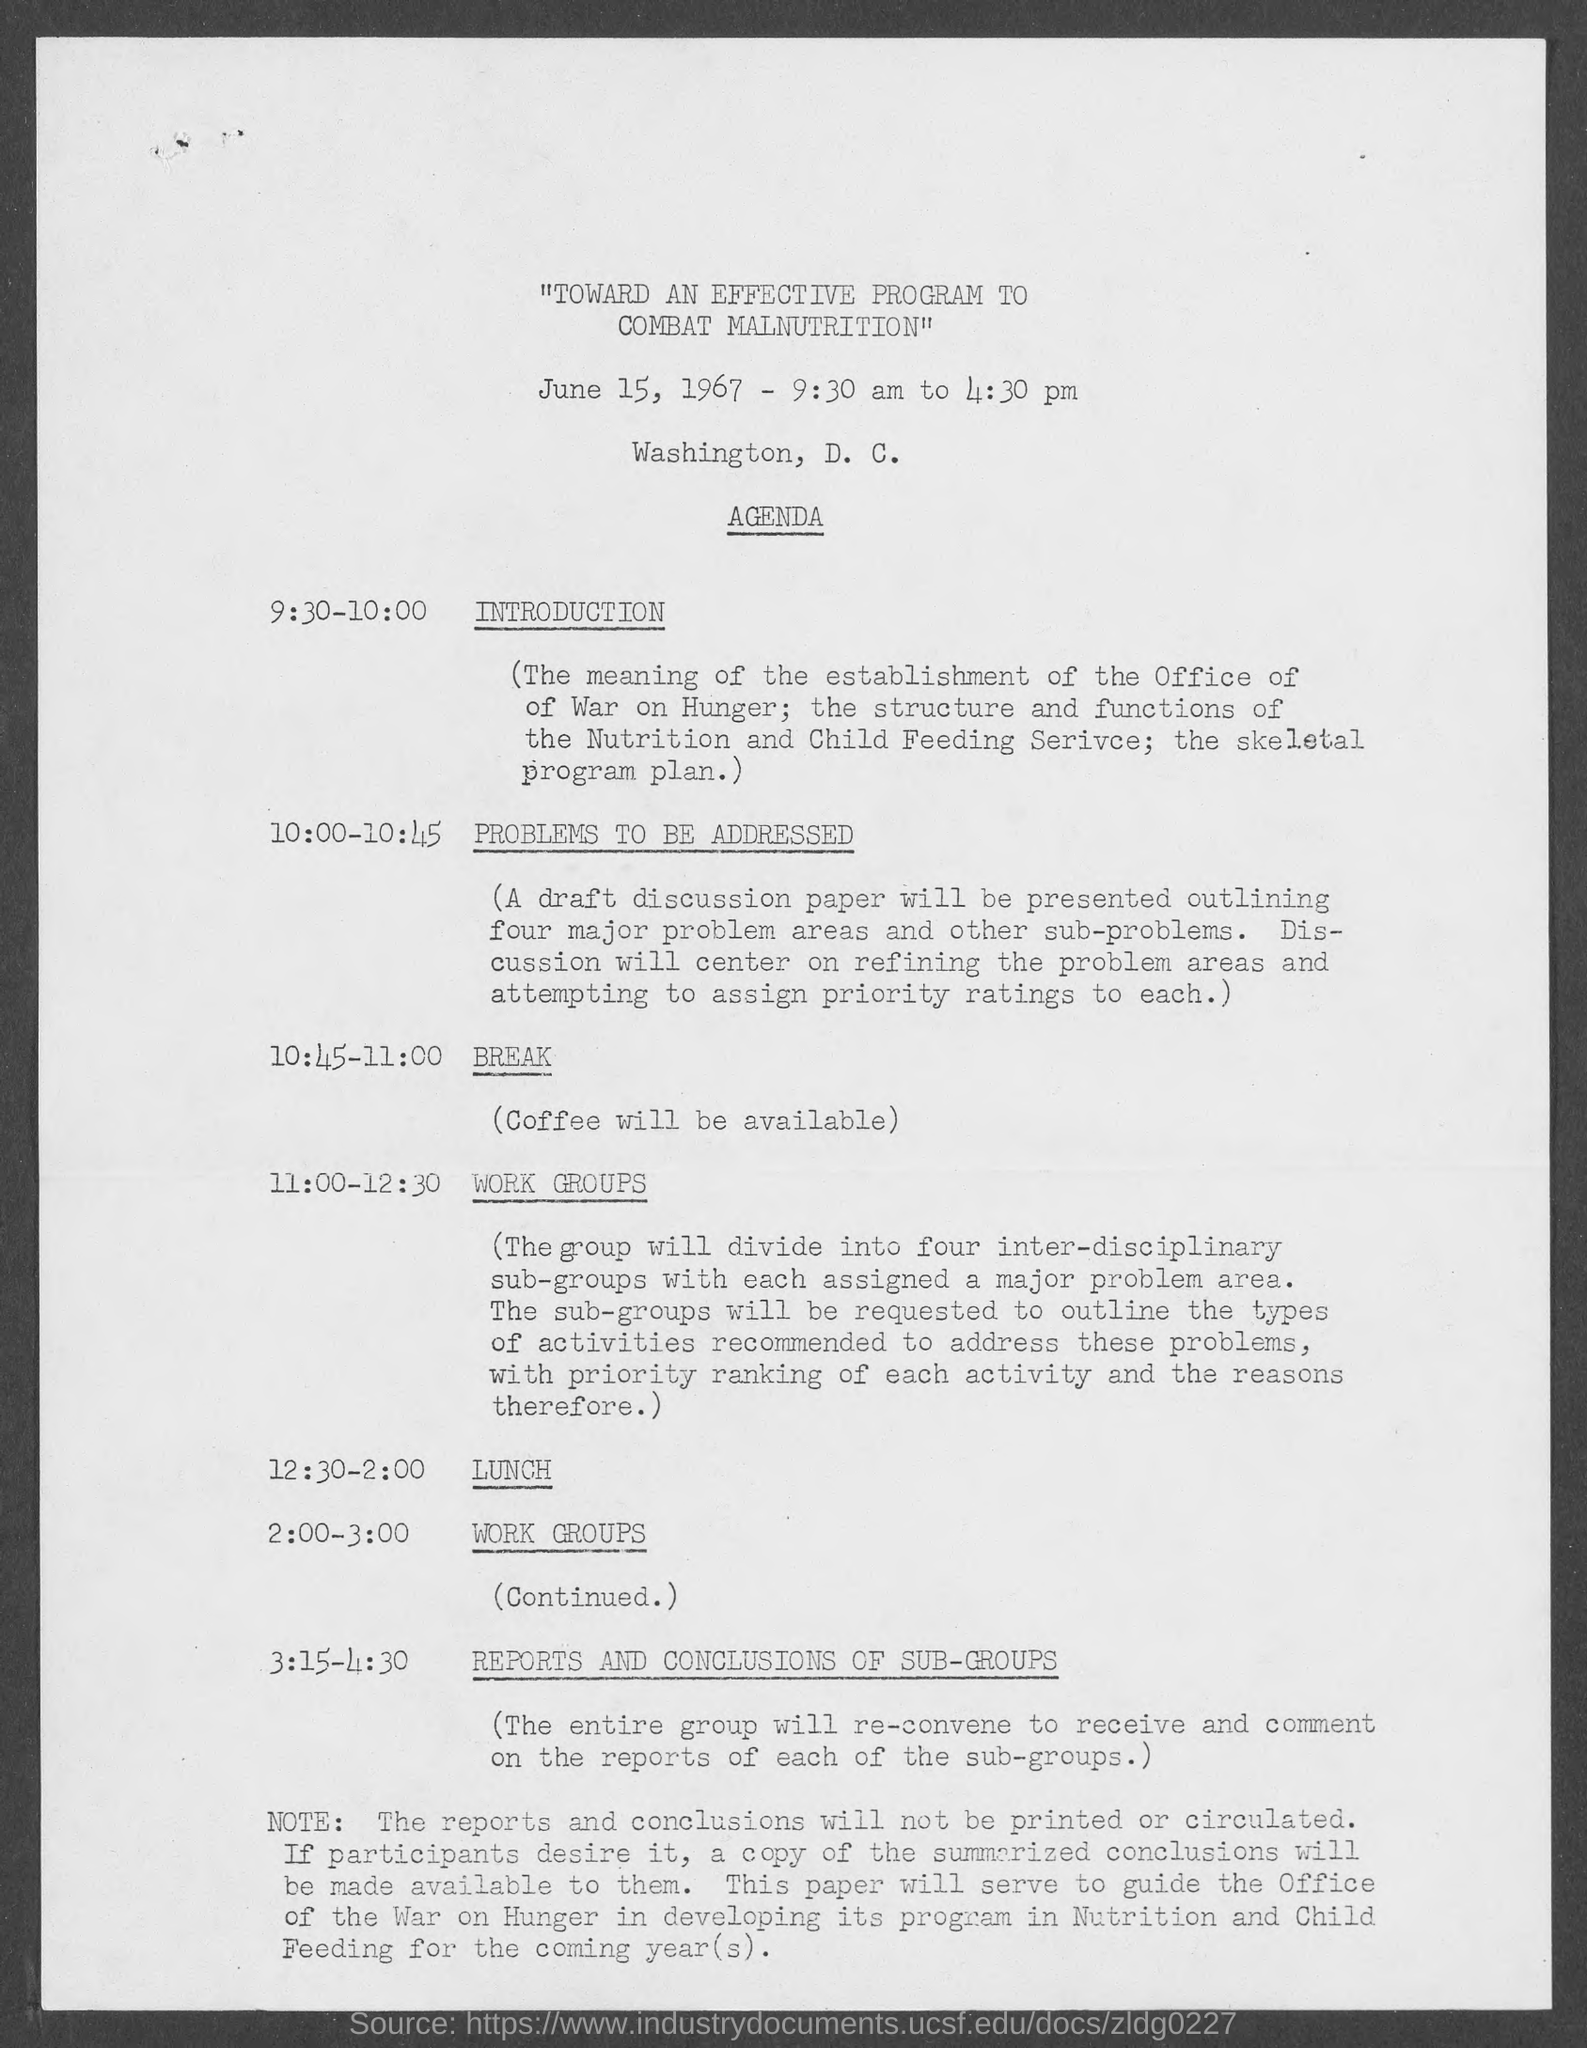Draw attention to some important aspects in this diagram. The program is scheduled for June 15, 1967. During the time period of 2:00 - 3:00, work groups are scheduled to perform tasks. The scheduled time for the program is from 9:30 am to 4:30 pm. At 10:45-11:00, the schedule is as follows: (pause). The schedule at 9:30-10:00 is as follows: 